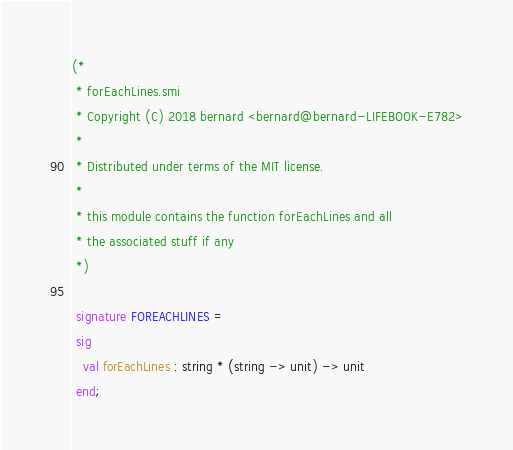<code> <loc_0><loc_0><loc_500><loc_500><_SML_>(*
 * forEachLines.smi
 * Copyright (C) 2018 bernard <bernard@bernard-LIFEBOOK-E782>
 *
 * Distributed under terms of the MIT license.
 *
 * this module contains the function forEachLines and all
 * the associated stuff if any
 *)

 signature FOREACHLINES =
 sig
   val forEachLines : string * (string -> unit) -> unit
 end;
</code> 